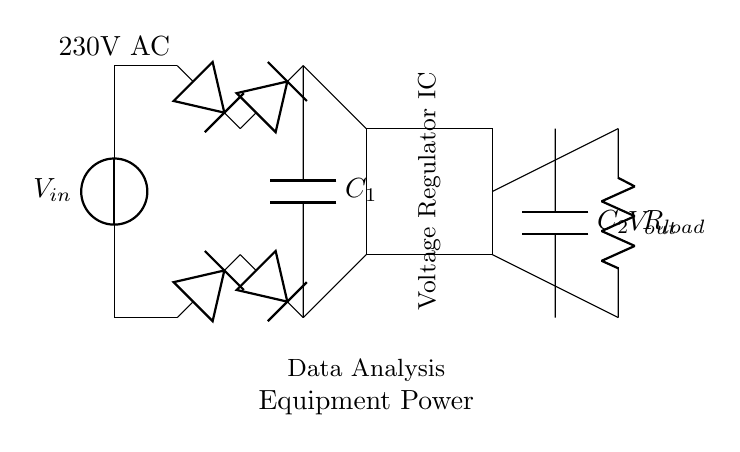What is the input voltage for the circuit? The input voltage is specified as 230V AC as indicated by the label next to the voltage source in the diagram.
Answer: 230V AC What is the function of the smoothing capacitor? The smoothing capacitor, labeled as C1, helps to reduce ripple in the rectified voltage by storing charge and releasing it to maintain a steady voltage after rectification.
Answer: Reduce ripple What is the output of the circuit? The circuit's output label indicates it is used to power data analysis equipment, which suggests that the voltage output will be stable and regulated for that purpose.
Answer: Vout What type of components are used in the rectifier bridge? The rectifier bridge consists of four diodes that work together to convert AC voltage into DC voltage by allowing current to flow in one direction, rectifying the input voltage.
Answer: Diodes How many capacitors are present in the circuit? There are two capacitors in the circuit: C1 (smoothing capacitor) and C2 (output capacitor). This is confirmed by the labels next to both capacitors in the diagram.
Answer: Two What is the role of the voltage regulator IC? The voltage regulator IC ensures that the output voltage remains consistent regardless of variations in input voltage or load conditions, which is essential for powering sensitive data analysis equipment reliably.
Answer: Regulate voltage 